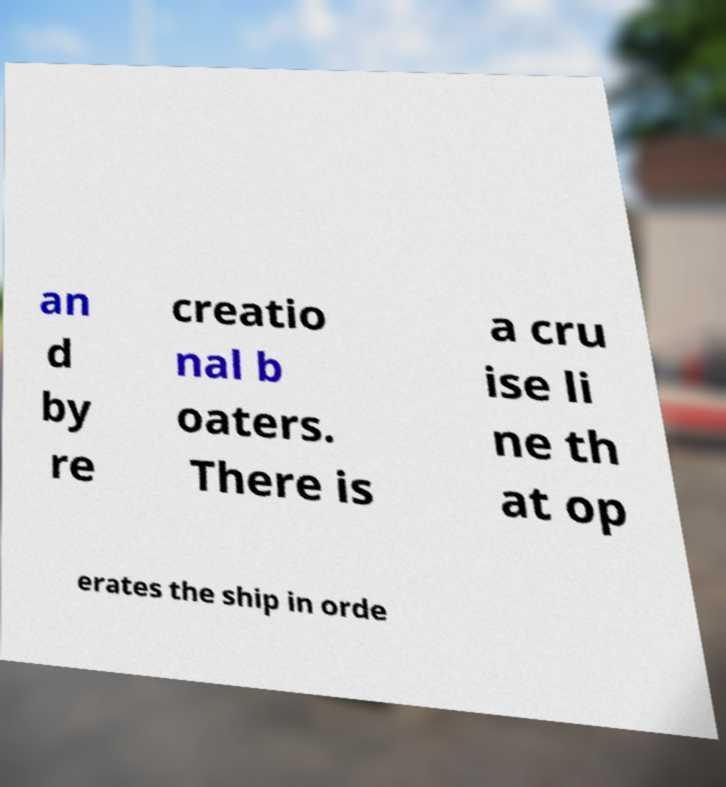Could you assist in decoding the text presented in this image and type it out clearly? an d by re creatio nal b oaters. There is a cru ise li ne th at op erates the ship in orde 